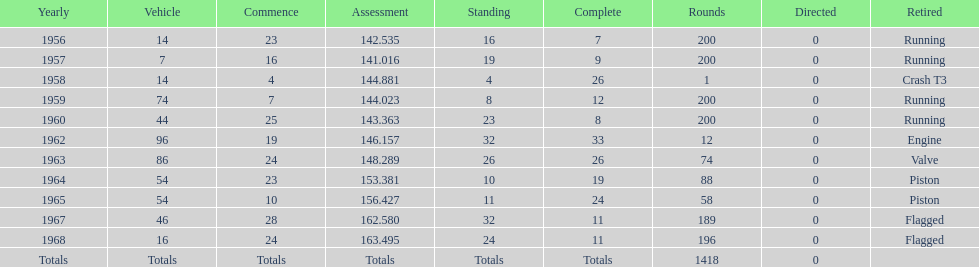How many times was bob veith ranked higher than 10 at an indy 500? 2. 